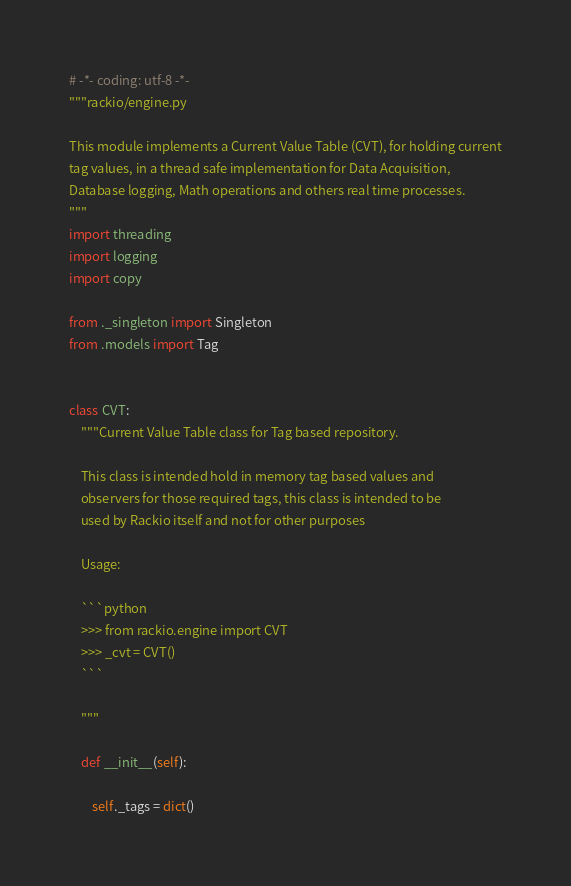Convert code to text. <code><loc_0><loc_0><loc_500><loc_500><_Python_># -*- coding: utf-8 -*-
"""rackio/engine.py

This module implements a Current Value Table (CVT), for holding current
tag values, in a thread safe implementation for Data Acquisition,
Database logging, Math operations and others real time processes.
"""
import threading
import logging
import copy

from ._singleton import Singleton
from .models import Tag


class CVT:
    """Current Value Table class for Tag based repository.

    This class is intended hold in memory tag based values and 
    observers for those required tags, this class is intended to be
    used by Rackio itself and not for other purposes

    Usage:
    
    ```python
    >>> from rackio.engine import CVT
    >>> _cvt = CVT()
    ```

    """

    def __init__(self):

        self._tags = dict()</code> 